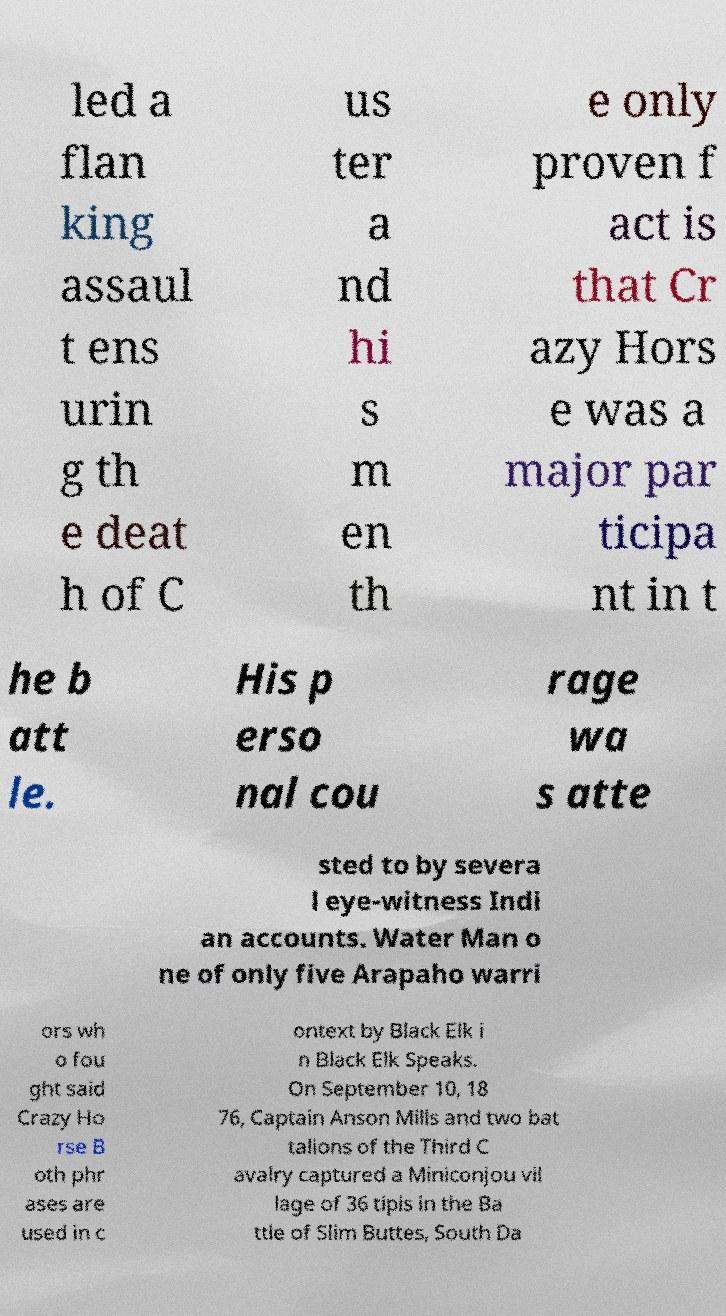Can you accurately transcribe the text from the provided image for me? led a flan king assaul t ens urin g th e deat h of C us ter a nd hi s m en th e only proven f act is that Cr azy Hors e was a major par ticipa nt in t he b att le. His p erso nal cou rage wa s atte sted to by severa l eye-witness Indi an accounts. Water Man o ne of only five Arapaho warri ors wh o fou ght said Crazy Ho rse B oth phr ases are used in c ontext by Black Elk i n Black Elk Speaks. On September 10, 18 76, Captain Anson Mills and two bat talions of the Third C avalry captured a Miniconjou vil lage of 36 tipis in the Ba ttle of Slim Buttes, South Da 